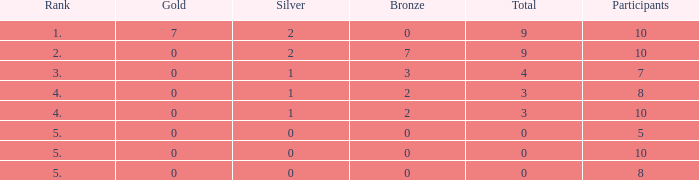What is the overall rank with a gold value less than 0? None. 